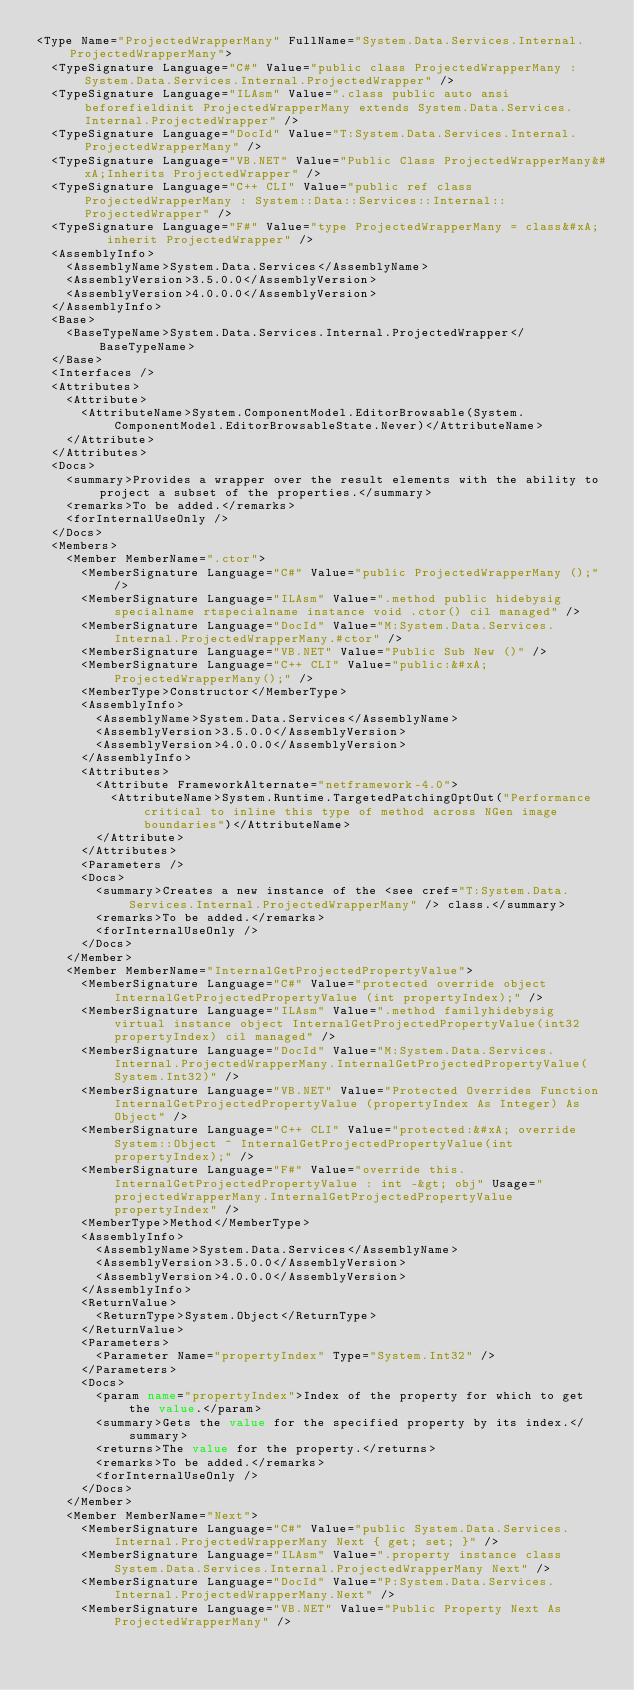Convert code to text. <code><loc_0><loc_0><loc_500><loc_500><_XML_><Type Name="ProjectedWrapperMany" FullName="System.Data.Services.Internal.ProjectedWrapperMany">
  <TypeSignature Language="C#" Value="public class ProjectedWrapperMany : System.Data.Services.Internal.ProjectedWrapper" />
  <TypeSignature Language="ILAsm" Value=".class public auto ansi beforefieldinit ProjectedWrapperMany extends System.Data.Services.Internal.ProjectedWrapper" />
  <TypeSignature Language="DocId" Value="T:System.Data.Services.Internal.ProjectedWrapperMany" />
  <TypeSignature Language="VB.NET" Value="Public Class ProjectedWrapperMany&#xA;Inherits ProjectedWrapper" />
  <TypeSignature Language="C++ CLI" Value="public ref class ProjectedWrapperMany : System::Data::Services::Internal::ProjectedWrapper" />
  <TypeSignature Language="F#" Value="type ProjectedWrapperMany = class&#xA;    inherit ProjectedWrapper" />
  <AssemblyInfo>
    <AssemblyName>System.Data.Services</AssemblyName>
    <AssemblyVersion>3.5.0.0</AssemblyVersion>
    <AssemblyVersion>4.0.0.0</AssemblyVersion>
  </AssemblyInfo>
  <Base>
    <BaseTypeName>System.Data.Services.Internal.ProjectedWrapper</BaseTypeName>
  </Base>
  <Interfaces />
  <Attributes>
    <Attribute>
      <AttributeName>System.ComponentModel.EditorBrowsable(System.ComponentModel.EditorBrowsableState.Never)</AttributeName>
    </Attribute>
  </Attributes>
  <Docs>
    <summary>Provides a wrapper over the result elements with the ability to project a subset of the properties.</summary>
    <remarks>To be added.</remarks>
    <forInternalUseOnly />
  </Docs>
  <Members>
    <Member MemberName=".ctor">
      <MemberSignature Language="C#" Value="public ProjectedWrapperMany ();" />
      <MemberSignature Language="ILAsm" Value=".method public hidebysig specialname rtspecialname instance void .ctor() cil managed" />
      <MemberSignature Language="DocId" Value="M:System.Data.Services.Internal.ProjectedWrapperMany.#ctor" />
      <MemberSignature Language="VB.NET" Value="Public Sub New ()" />
      <MemberSignature Language="C++ CLI" Value="public:&#xA; ProjectedWrapperMany();" />
      <MemberType>Constructor</MemberType>
      <AssemblyInfo>
        <AssemblyName>System.Data.Services</AssemblyName>
        <AssemblyVersion>3.5.0.0</AssemblyVersion>
        <AssemblyVersion>4.0.0.0</AssemblyVersion>
      </AssemblyInfo>
      <Attributes>
        <Attribute FrameworkAlternate="netframework-4.0">
          <AttributeName>System.Runtime.TargetedPatchingOptOut("Performance critical to inline this type of method across NGen image boundaries")</AttributeName>
        </Attribute>
      </Attributes>
      <Parameters />
      <Docs>
        <summary>Creates a new instance of the <see cref="T:System.Data.Services.Internal.ProjectedWrapperMany" /> class.</summary>
        <remarks>To be added.</remarks>
        <forInternalUseOnly />
      </Docs>
    </Member>
    <Member MemberName="InternalGetProjectedPropertyValue">
      <MemberSignature Language="C#" Value="protected override object InternalGetProjectedPropertyValue (int propertyIndex);" />
      <MemberSignature Language="ILAsm" Value=".method familyhidebysig virtual instance object InternalGetProjectedPropertyValue(int32 propertyIndex) cil managed" />
      <MemberSignature Language="DocId" Value="M:System.Data.Services.Internal.ProjectedWrapperMany.InternalGetProjectedPropertyValue(System.Int32)" />
      <MemberSignature Language="VB.NET" Value="Protected Overrides Function InternalGetProjectedPropertyValue (propertyIndex As Integer) As Object" />
      <MemberSignature Language="C++ CLI" Value="protected:&#xA; override System::Object ^ InternalGetProjectedPropertyValue(int propertyIndex);" />
      <MemberSignature Language="F#" Value="override this.InternalGetProjectedPropertyValue : int -&gt; obj" Usage="projectedWrapperMany.InternalGetProjectedPropertyValue propertyIndex" />
      <MemberType>Method</MemberType>
      <AssemblyInfo>
        <AssemblyName>System.Data.Services</AssemblyName>
        <AssemblyVersion>3.5.0.0</AssemblyVersion>
        <AssemblyVersion>4.0.0.0</AssemblyVersion>
      </AssemblyInfo>
      <ReturnValue>
        <ReturnType>System.Object</ReturnType>
      </ReturnValue>
      <Parameters>
        <Parameter Name="propertyIndex" Type="System.Int32" />
      </Parameters>
      <Docs>
        <param name="propertyIndex">Index of the property for which to get the value.</param>
        <summary>Gets the value for the specified property by its index.</summary>
        <returns>The value for the property.</returns>
        <remarks>To be added.</remarks>
        <forInternalUseOnly />
      </Docs>
    </Member>
    <Member MemberName="Next">
      <MemberSignature Language="C#" Value="public System.Data.Services.Internal.ProjectedWrapperMany Next { get; set; }" />
      <MemberSignature Language="ILAsm" Value=".property instance class System.Data.Services.Internal.ProjectedWrapperMany Next" />
      <MemberSignature Language="DocId" Value="P:System.Data.Services.Internal.ProjectedWrapperMany.Next" />
      <MemberSignature Language="VB.NET" Value="Public Property Next As ProjectedWrapperMany" /></code> 